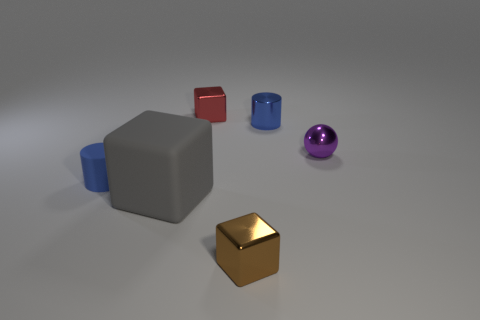Is there any other thing that is the same shape as the small purple shiny object?
Make the answer very short. No. What number of objects are either green rubber objects or large blocks to the left of the small brown cube?
Ensure brevity in your answer.  1. What color is the ball that is the same material as the red cube?
Provide a short and direct response. Purple. What number of things are cyan metal spheres or large rubber things?
Give a very brief answer. 1. There is a metallic sphere that is the same size as the brown cube; what is its color?
Provide a short and direct response. Purple. How many objects are cylinders behind the purple shiny thing or small cyan blocks?
Keep it short and to the point. 1. What number of other objects are there of the same size as the brown metallic thing?
Your response must be concise. 4. How big is the cylinder right of the tiny red shiny cube?
Offer a very short reply. Small. There is a tiny red object that is made of the same material as the sphere; what is its shape?
Make the answer very short. Cube. Are there any other things that are the same color as the tiny rubber object?
Your answer should be compact. Yes. 